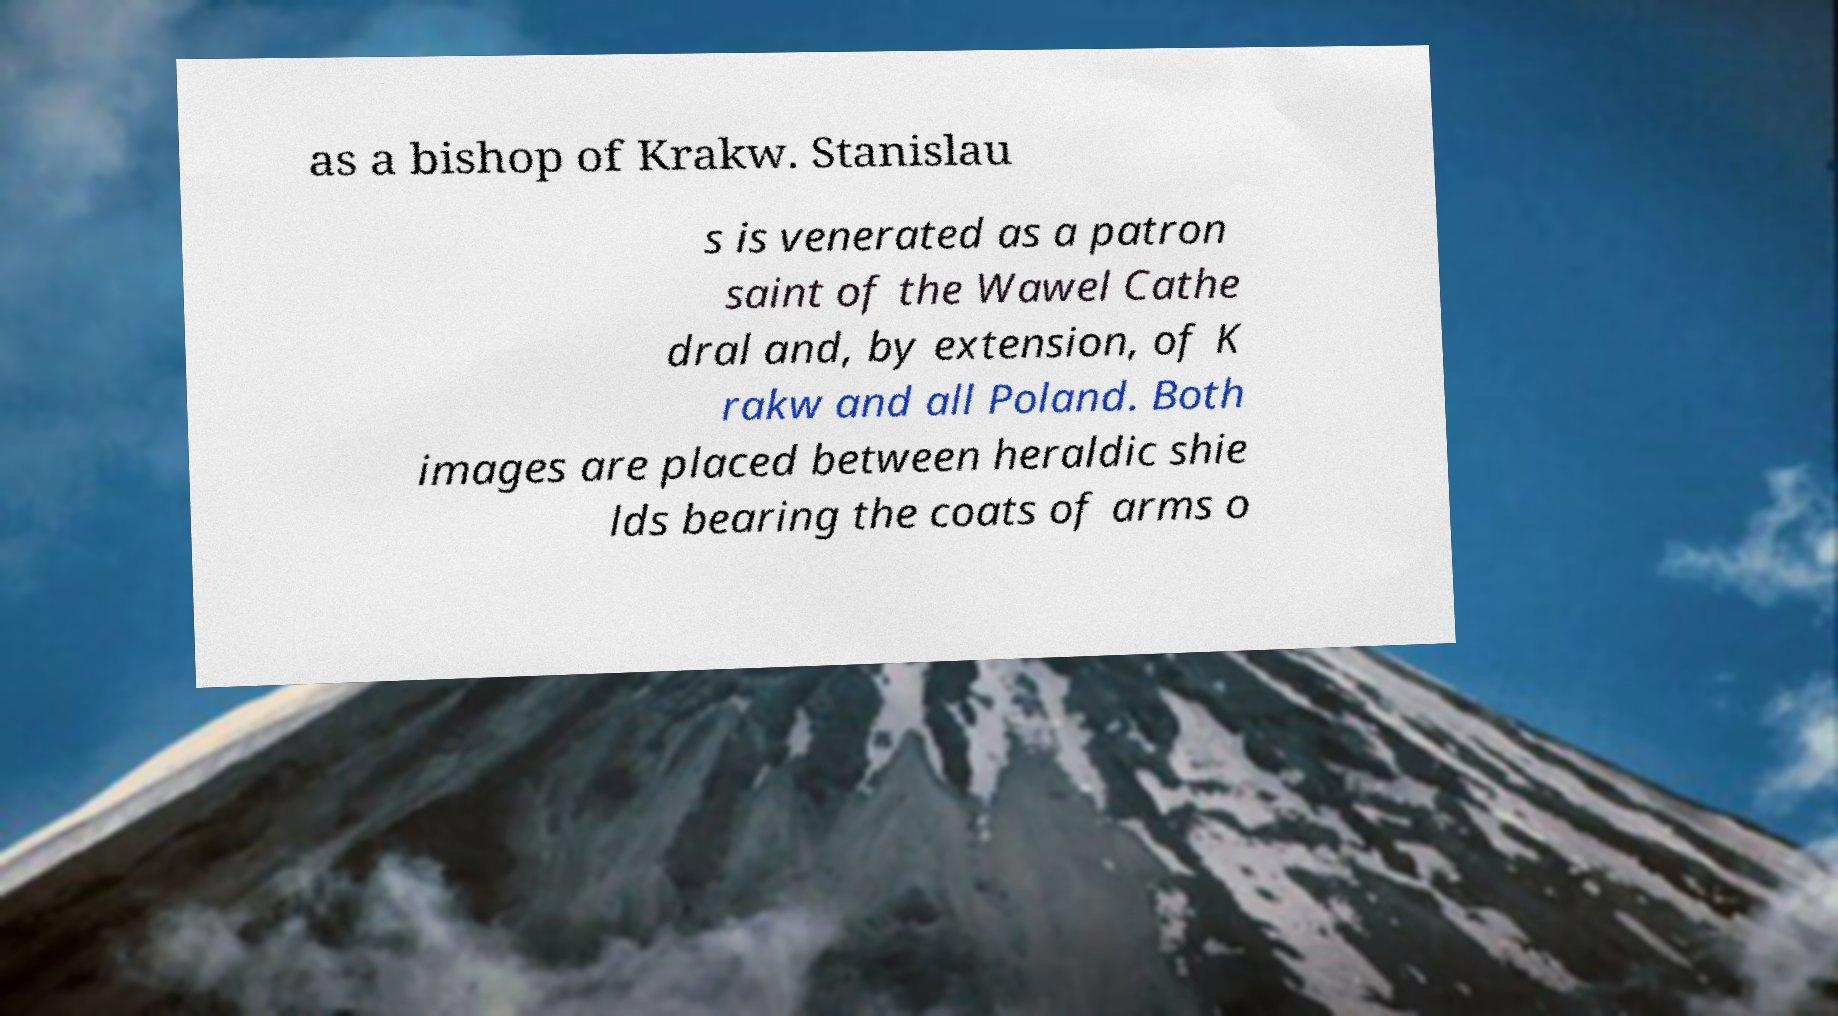Can you read and provide the text displayed in the image?This photo seems to have some interesting text. Can you extract and type it out for me? as a bishop of Krakw. Stanislau s is venerated as a patron saint of the Wawel Cathe dral and, by extension, of K rakw and all Poland. Both images are placed between heraldic shie lds bearing the coats of arms o 